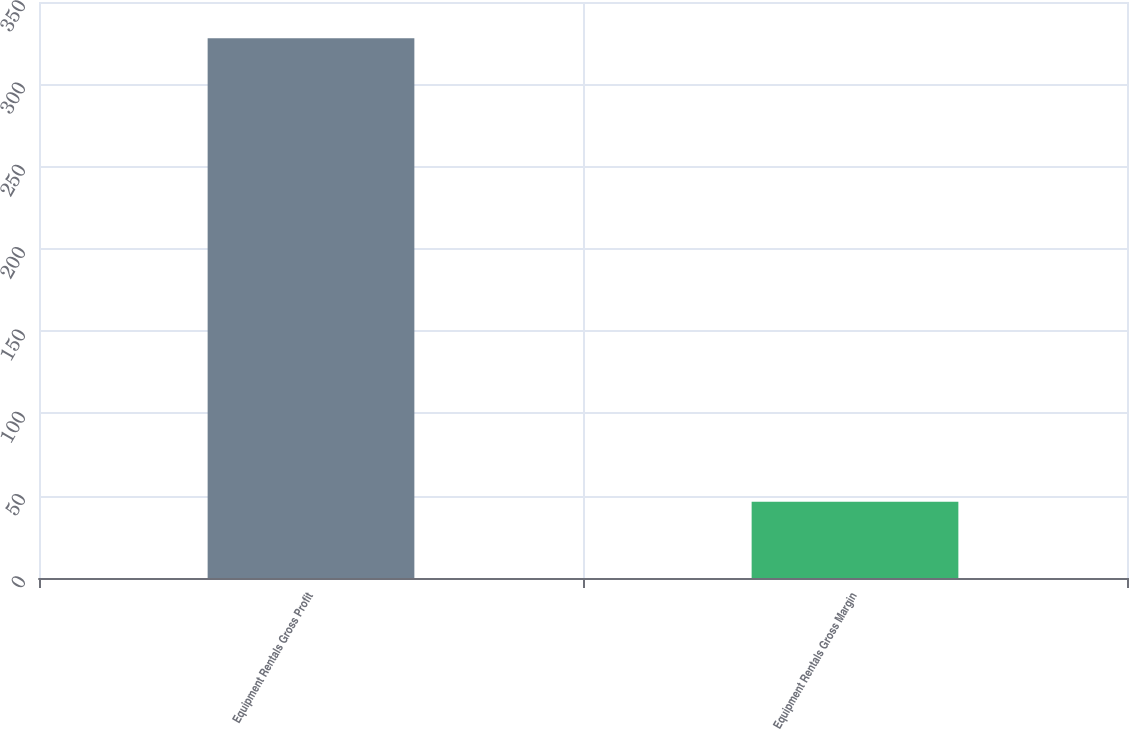Convert chart. <chart><loc_0><loc_0><loc_500><loc_500><bar_chart><fcel>Equipment Rentals Gross Profit<fcel>Equipment Rentals Gross Margin<nl><fcel>328<fcel>46.3<nl></chart> 